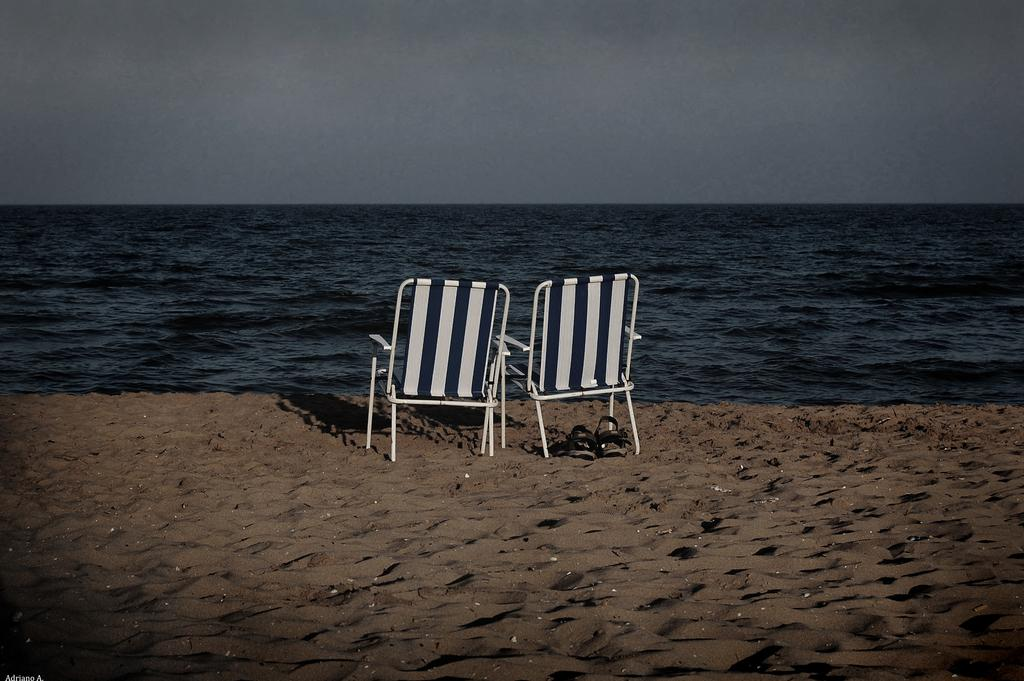How many chairs are in the image? There are two chairs in the image. What else can be seen on the ground in the image? There is footwear on the sand in the image. What is visible in the background of the image? Water and the sky are visible in the background of the image. What type of copper material can be seen in the image? There is no copper material present in the image. How many dolls are visible in the image? There are no dolls present in the image. 